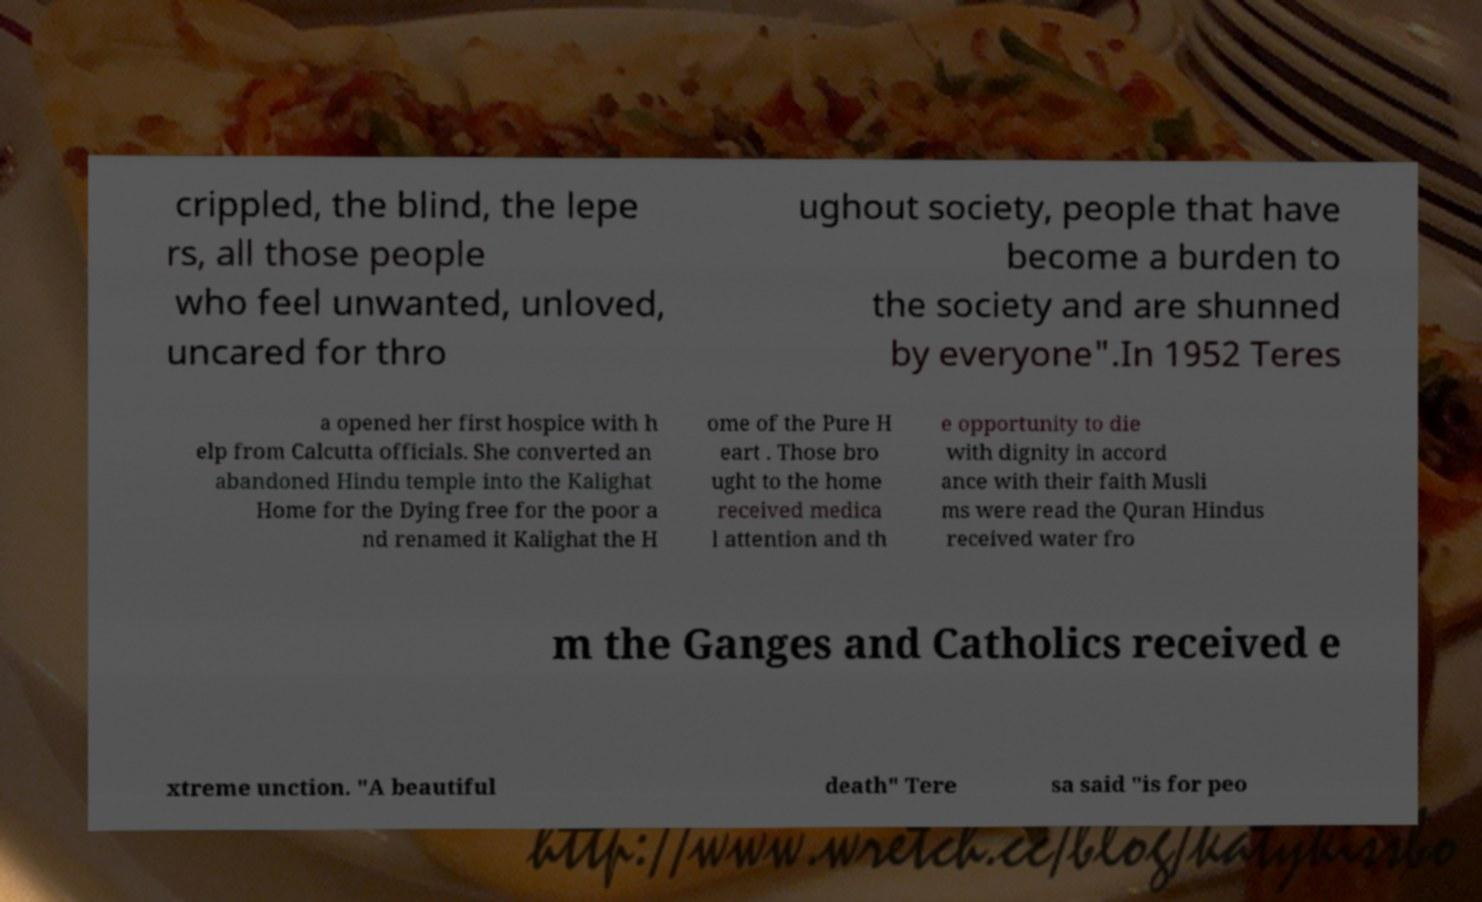Please identify and transcribe the text found in this image. crippled, the blind, the lepe rs, all those people who feel unwanted, unloved, uncared for thro ughout society, people that have become a burden to the society and are shunned by everyone".In 1952 Teres a opened her first hospice with h elp from Calcutta officials. She converted an abandoned Hindu temple into the Kalighat Home for the Dying free for the poor a nd renamed it Kalighat the H ome of the Pure H eart . Those bro ught to the home received medica l attention and th e opportunity to die with dignity in accord ance with their faith Musli ms were read the Quran Hindus received water fro m the Ganges and Catholics received e xtreme unction. "A beautiful death" Tere sa said "is for peo 